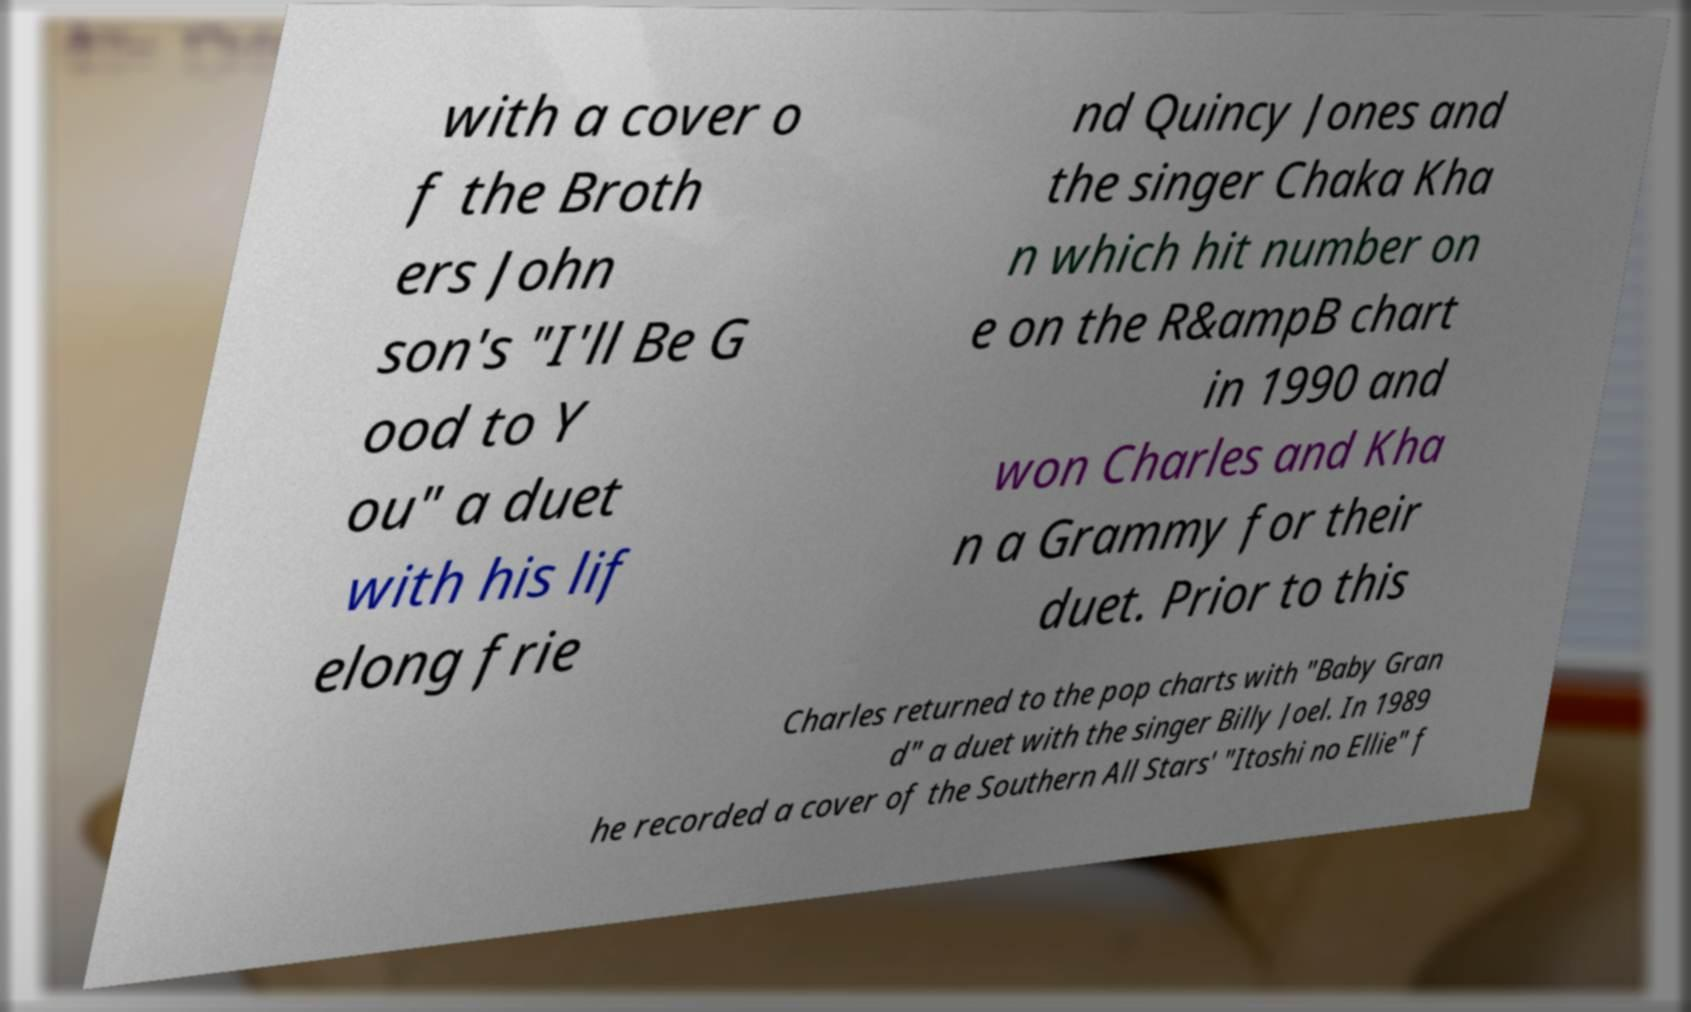For documentation purposes, I need the text within this image transcribed. Could you provide that? with a cover o f the Broth ers John son's "I'll Be G ood to Y ou" a duet with his lif elong frie nd Quincy Jones and the singer Chaka Kha n which hit number on e on the R&ampB chart in 1990 and won Charles and Kha n a Grammy for their duet. Prior to this Charles returned to the pop charts with "Baby Gran d" a duet with the singer Billy Joel. In 1989 he recorded a cover of the Southern All Stars' "Itoshi no Ellie" f 